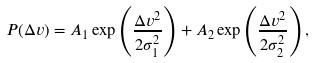Convert formula to latex. <formula><loc_0><loc_0><loc_500><loc_500>P ( \Delta v ) = A _ { 1 } \exp \left ( \frac { \Delta v ^ { 2 } } { 2 \sigma ^ { 2 } _ { 1 } } \right ) + A _ { 2 } \exp \left ( \frac { \Delta v ^ { 2 } } { 2 \sigma ^ { 2 } _ { 2 } } \right ) ,</formula> 